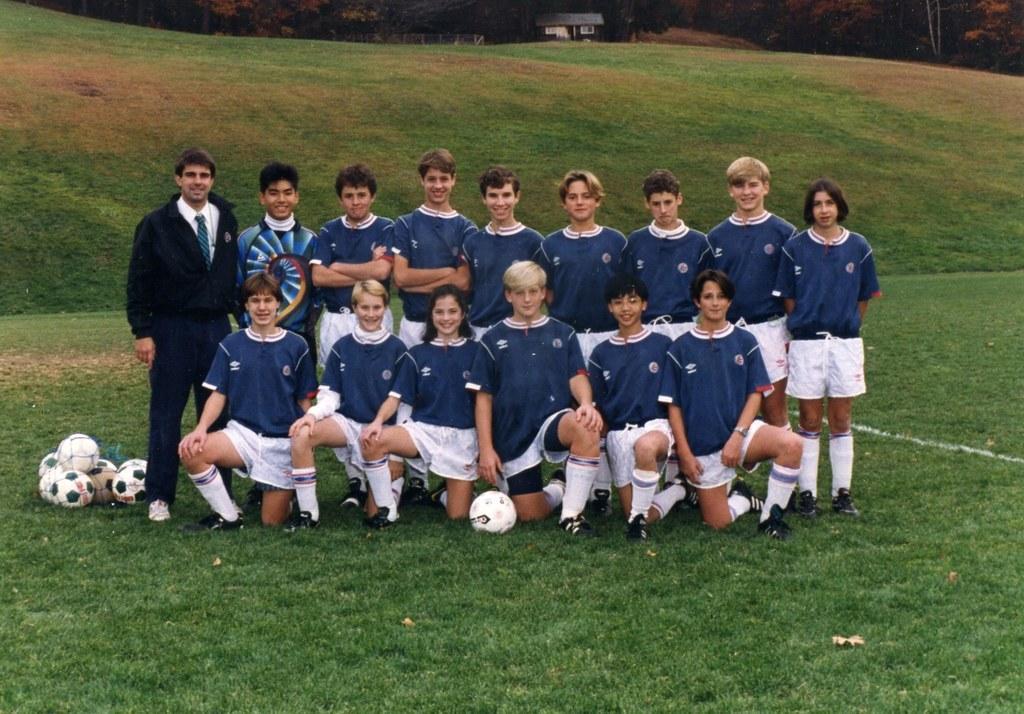In one or two sentences, can you explain what this image depicts? In this image I can see few persons. I can see few balls. I can see some grass on the ground. 